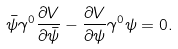Convert formula to latex. <formula><loc_0><loc_0><loc_500><loc_500>\bar { \psi } \gamma ^ { 0 } \frac { \partial V } { \partial \bar { \psi } } - \frac { \partial V } { \partial \psi } \gamma ^ { 0 } \psi = 0 .</formula> 